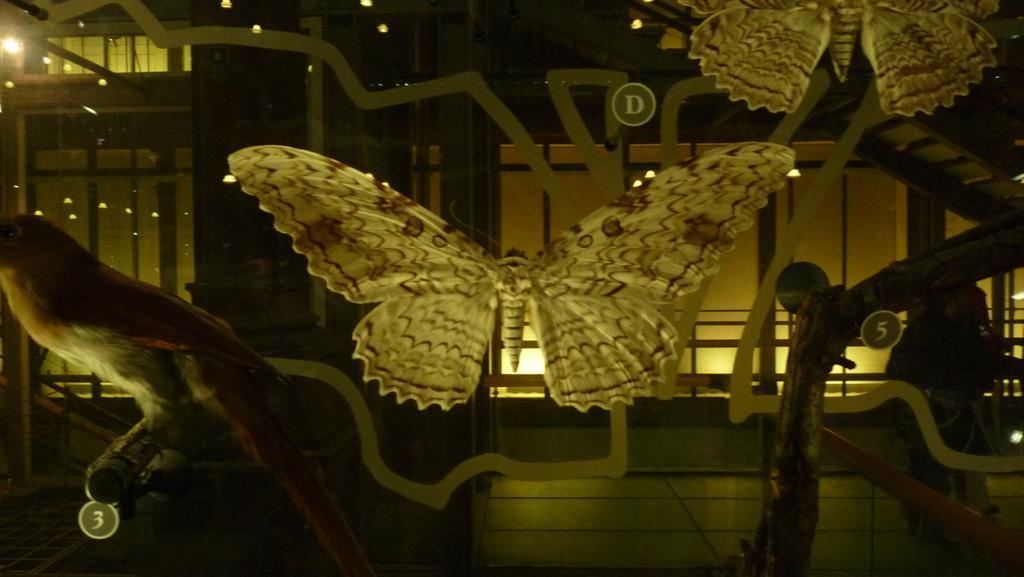Please provide a concise description of this image. In this image, we can see some toy butterflies and a bird. We can see a person and some stairs. We can see the glass and some lights. 